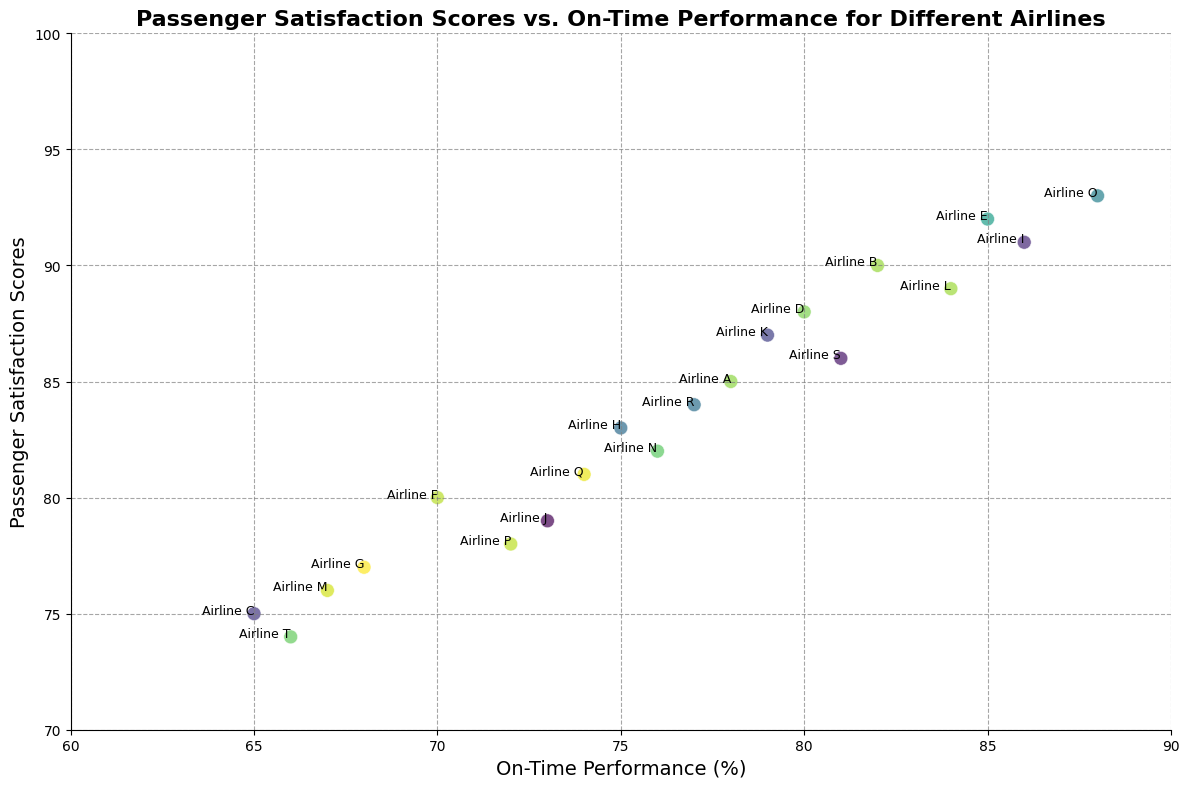What's the average passenger satisfaction score for airlines with on-time performance above 80%? Identify all airlines with on-time performance above 80%, then sum their satisfaction scores and divide by the number of such airlines. In this case, the airlines are B (90), D (88), E (92), I (91), K (87), L (89), O (93), S (86). Sum: 90 + 88 + 92 + 91 + 87 + 89 + 93 + 86 = 716. The average is 716 / 8 = 89.5
Answer: 89.5 Which airline has the highest passenger satisfaction score? Locate the point with the highest y-value (passenger satisfaction score) on the chart. Airline O has the highest satisfaction score of 93.
Answer: Airline O Which two airlines have the most similar on-time performance but different passenger satisfaction scores? Compare the x-values (on-time performance) of all points and look for pairs with close x-values but noticeably different y-values (satisfaction scores). Airlines D and K both have on-time performance of 80% and 79% respectively, but their satisfaction scores are 88 and 87.
Answer: Airlines D and K Among airlines with on-time performance less than 75%, which has the highest passenger satisfaction score? Identify all airlines with on-time performance below 75%, then find the one with the highest satisfaction score. The airlines are C (75), F (80), G (77), J (79), M (76), P (78), Q (81), R (84), T (74). Among these, Airline F has the highest satisfaction score of 80.
Answer: Airline F What is the correlation between passenger satisfaction scores and on-time performance? Look at the general trend of the scatter plot. If points are trending upwards from left to right, there's a positive correlation. Here, an upward trend suggests a positive correlation.
Answer: Positive correlation Which airline has the lowest on-time performance, and what is its passenger satisfaction score? Find the airline with the lowest x-value (on-time performance) and check its corresponding y-value (passenger satisfaction score). Airline T has the lowest on-time performance (66%) with a satisfaction score of 74.
Answer: Airline T, 74 If an airline has an on-time performance of 84%, what is the expected range of its passenger satisfaction score based on the visual trend? Estimate the y-values (satisfaction scores) of nearby points with similar x-values (on-time performance). Airlines L (84-89) and S (81-86) are close-by, with satisfaction scores ranging from 86 to 89. Therefore, the expected satisfaction score range is between 86 and 89.
Answer: 86 to 89 Which pair of airlines has the greatest difference in passenger satisfaction scores despite similar on-time performance? Compare x-values (on-time performance) and y-values (satisfaction scores) to find pairs with small differences in x but large differences in y. Airlines E (85 - 92) and F (70 - 80) have similar on-time performance but a notable difference in satisfaction scores. Difference: 92 - 80 = 12.
Answer: Airlines E and F What is the average on-time performance for airlines with a passenger satisfaction score above 85? Identify airlines with passenger satisfaction scores above 85, sum their on-time performance, and divide by the number of such airlines. The airlines are A (78), B (82), D (80), E (85), I (86), K (79), L (84), O (88), S (81). Sum: 78 + 82 + 80 + 85 + 86 + 79 + 84 + 88 + 81 = 743. Average: 743 / 9 = 82.56
Answer: 82.56 